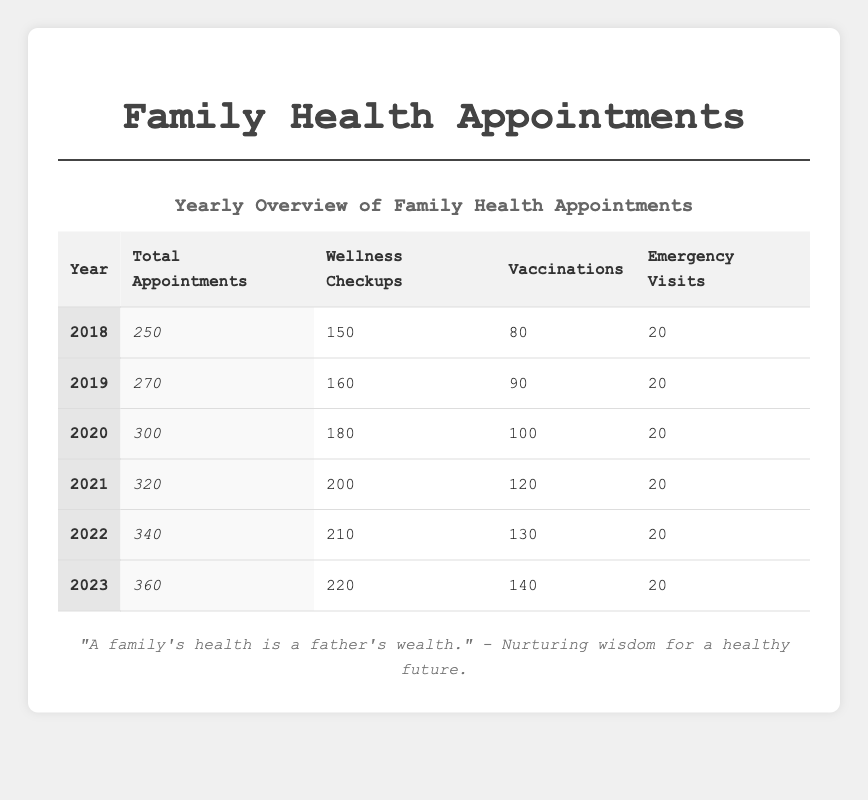What was the total number of appointments in 2020? According to the table, the total number of appointments listed for the year 2020 is 300.
Answer: 300 How many wellness checkups were conducted in 2021? The data for the year 2021 shows that there were 200 wellness checkups.
Answer: 200 What year had the highest number of vaccinations? By reviewing the table, the highest number of vaccinations was in 2023, with a total of 140 vaccinations.
Answer: 2023 How many more total appointments were there in 2023 compared to 2018? In 2023, there were 360 total appointments and in 2018, there were 250. The difference is 360 - 250 = 110.
Answer: 110 What is the average number of emergency visits from 2018 to 2023? The number of emergency visits each year is consistent at 20. Since there are 6 years, the average is 20/1 = 20.
Answer: 20 Did the number of wellness checkups increase every year from 2018 to 2023? Checking the values, we see that wellness checkups increased from 150 in 2018 to 220 in 2023, indicating consistent growth each year.
Answer: Yes Which year had the least number of total appointments and what was that number? From the table, 2018 had the least total appointments at 250.
Answer: 2018, 250 What was the total number of wellness checkups from 2019 to 2022? The wellness checkups for those years are 160 (2019), 180 (2020), 200 (2021), and 210 (2022). Adding these gives: 160 + 180 + 200 + 210 = 750.
Answer: 750 What percentage of total appointments were wellness checkups in 2022? For 2022, there were 340 total appointments and 210 were wellness checkups. The percentage is (210/340) * 100 = 61.76%.
Answer: 61.76% If we look at the total number of vaccinations from 2020 to 2023, what is the total? The vaccinations in those years are 100 (2020), 120 (2021), 130 (2022), and 140 (2023). The total is: 100 + 120 + 130 + 140 = 490.
Answer: 490 